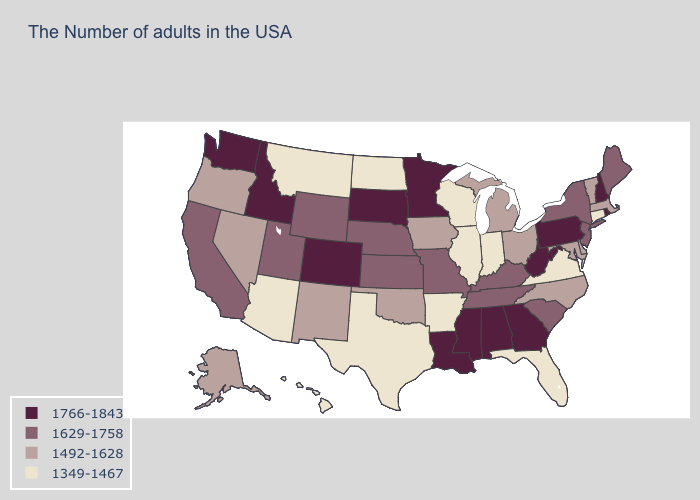What is the value of Iowa?
Concise answer only. 1492-1628. What is the value of New Hampshire?
Short answer required. 1766-1843. Does the first symbol in the legend represent the smallest category?
Give a very brief answer. No. Does New Mexico have the same value as Maine?
Give a very brief answer. No. Which states have the lowest value in the MidWest?
Short answer required. Indiana, Wisconsin, Illinois, North Dakota. Does Arizona have a lower value than Oregon?
Quick response, please. Yes. What is the value of Massachusetts?
Quick response, please. 1492-1628. What is the value of Colorado?
Give a very brief answer. 1766-1843. Among the states that border Nevada , does Oregon have the highest value?
Keep it brief. No. Name the states that have a value in the range 1492-1628?
Concise answer only. Massachusetts, Vermont, Delaware, Maryland, North Carolina, Ohio, Michigan, Iowa, Oklahoma, New Mexico, Nevada, Oregon, Alaska. Name the states that have a value in the range 1766-1843?
Give a very brief answer. Rhode Island, New Hampshire, Pennsylvania, West Virginia, Georgia, Alabama, Mississippi, Louisiana, Minnesota, South Dakota, Colorado, Idaho, Washington. Among the states that border Pennsylvania , which have the lowest value?
Write a very short answer. Delaware, Maryland, Ohio. Is the legend a continuous bar?
Be succinct. No. Which states have the lowest value in the Northeast?
Be succinct. Connecticut. What is the value of Massachusetts?
Be succinct. 1492-1628. 